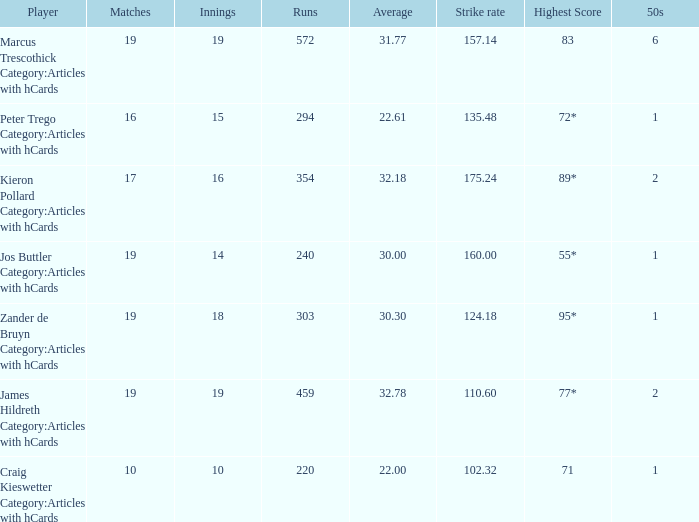What is the number of innings for the player who has a 22.61 average? 15.0. 